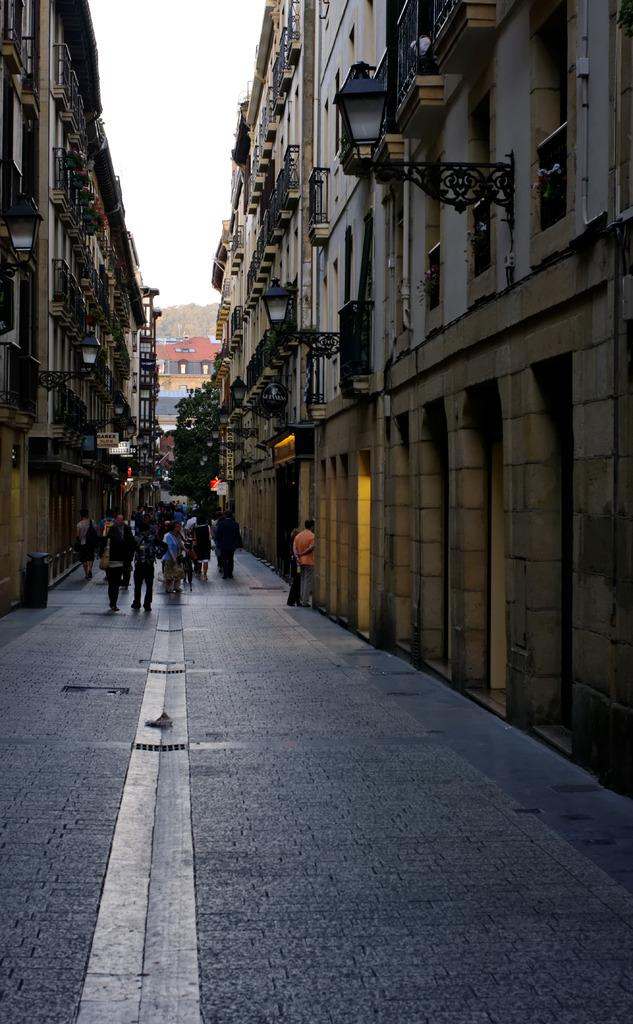What is the main focus of the image? The main focus of the image is the many people in the middle of the image. What can be seen on the left side of the image? There are buildings on the left side of the image. What can be seen on the right side of the image? There are buildings on the right side of the image. What is at the bottom of the image? There is a road at the bottom of the image. What is visible in the background of the image? There are houses, a hill, and the sky visible in the background of the image. What type of marble is being used to build the houses in the image? There is no mention of marble being used to build the houses in the image. The houses are not described in detail, so we cannot determine the materials used in their construction. 